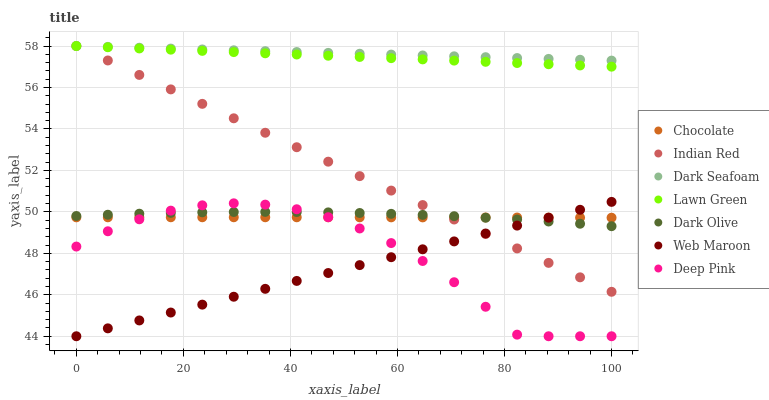Does Web Maroon have the minimum area under the curve?
Answer yes or no. Yes. Does Dark Seafoam have the maximum area under the curve?
Answer yes or no. Yes. Does Deep Pink have the minimum area under the curve?
Answer yes or no. No. Does Deep Pink have the maximum area under the curve?
Answer yes or no. No. Is Lawn Green the smoothest?
Answer yes or no. Yes. Is Deep Pink the roughest?
Answer yes or no. Yes. Is Dark Olive the smoothest?
Answer yes or no. No. Is Dark Olive the roughest?
Answer yes or no. No. Does Deep Pink have the lowest value?
Answer yes or no. Yes. Does Dark Olive have the lowest value?
Answer yes or no. No. Does Indian Red have the highest value?
Answer yes or no. Yes. Does Deep Pink have the highest value?
Answer yes or no. No. Is Deep Pink less than Indian Red?
Answer yes or no. Yes. Is Dark Seafoam greater than Web Maroon?
Answer yes or no. Yes. Does Dark Olive intersect Deep Pink?
Answer yes or no. Yes. Is Dark Olive less than Deep Pink?
Answer yes or no. No. Is Dark Olive greater than Deep Pink?
Answer yes or no. No. Does Deep Pink intersect Indian Red?
Answer yes or no. No. 